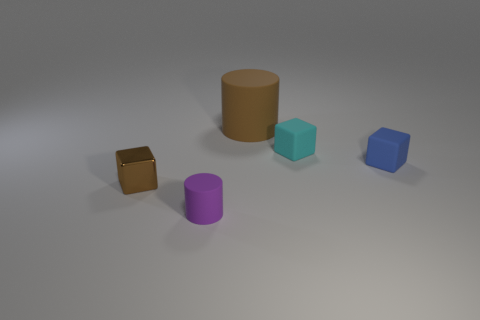What is the shape of the tiny cyan object that is made of the same material as the big brown cylinder?
Provide a succinct answer. Cube. How many large things have the same color as the big rubber cylinder?
Give a very brief answer. 0. What number of objects are tiny metal cubes or purple cylinders?
Your answer should be compact. 2. What material is the object that is on the left side of the tiny rubber thing that is in front of the tiny metallic thing?
Make the answer very short. Metal. Is there a gray cylinder made of the same material as the blue cube?
Provide a succinct answer. No. There is a rubber object in front of the block that is on the left side of the cylinder right of the purple thing; what is its shape?
Your answer should be very brief. Cylinder. What is the small purple thing made of?
Keep it short and to the point. Rubber. The big cylinder that is the same material as the small cylinder is what color?
Offer a very short reply. Brown. There is a cylinder left of the large matte cylinder; are there any objects to the right of it?
Provide a succinct answer. Yes. What number of other things are the same shape as the metallic thing?
Your response must be concise. 2. 